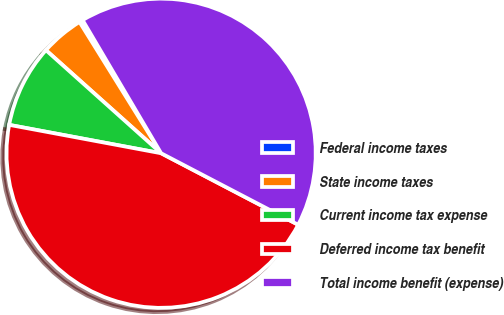<chart> <loc_0><loc_0><loc_500><loc_500><pie_chart><fcel>Federal income taxes<fcel>State income taxes<fcel>Current income tax expense<fcel>Deferred income tax benefit<fcel>Total income benefit (expense)<nl><fcel>0.37%<fcel>4.53%<fcel>8.68%<fcel>45.29%<fcel>41.14%<nl></chart> 